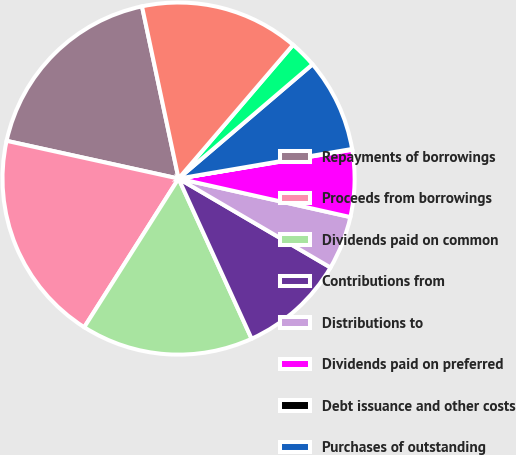<chart> <loc_0><loc_0><loc_500><loc_500><pie_chart><fcel>Repayments of borrowings<fcel>Proceeds from borrowings<fcel>Dividends paid on common<fcel>Contributions from<fcel>Distributions to<fcel>Dividends paid on preferred<fcel>Debt issuance and other costs<fcel>Purchases of outstanding<fcel>Proceeds received from<fcel>Acquisition of convertible<nl><fcel>18.23%<fcel>19.44%<fcel>15.81%<fcel>9.76%<fcel>4.92%<fcel>6.13%<fcel>0.07%<fcel>8.55%<fcel>2.49%<fcel>14.6%<nl></chart> 